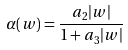<formula> <loc_0><loc_0><loc_500><loc_500>\alpha ( w ) = \frac { a _ { 2 } | w | } { 1 + a _ { 3 } | w | }</formula> 